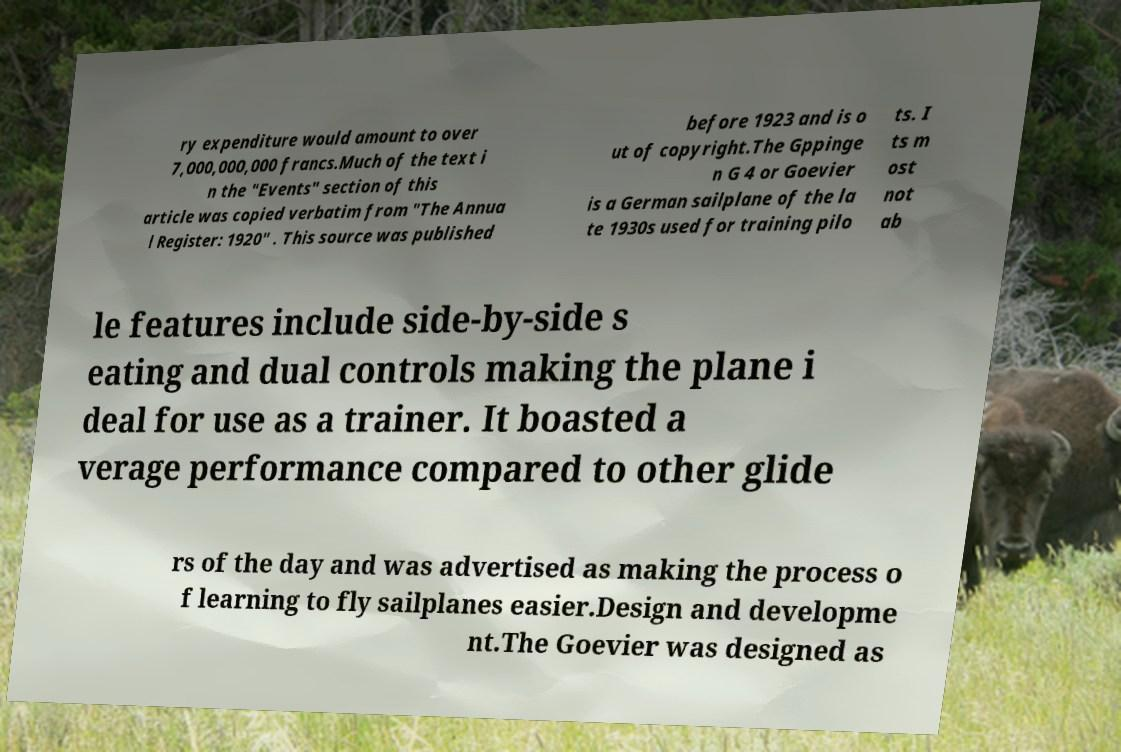Can you accurately transcribe the text from the provided image for me? ry expenditure would amount to over 7,000,000,000 francs.Much of the text i n the "Events" section of this article was copied verbatim from "The Annua l Register: 1920" . This source was published before 1923 and is o ut of copyright.The Gppinge n G 4 or Goevier is a German sailplane of the la te 1930s used for training pilo ts. I ts m ost not ab le features include side-by-side s eating and dual controls making the plane i deal for use as a trainer. It boasted a verage performance compared to other glide rs of the day and was advertised as making the process o f learning to fly sailplanes easier.Design and developme nt.The Goevier was designed as 